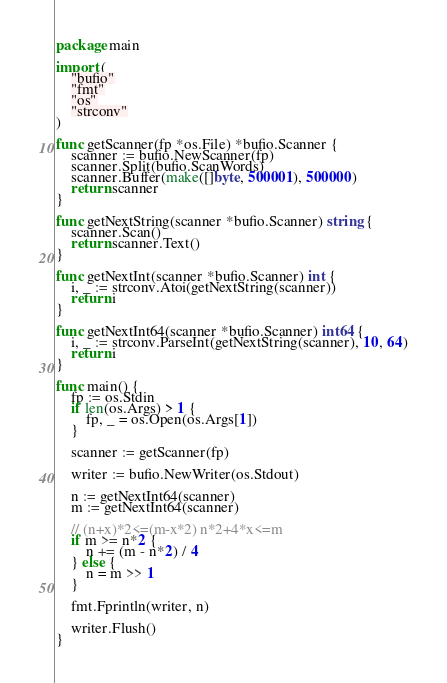Convert code to text. <code><loc_0><loc_0><loc_500><loc_500><_Go_>package main

import (
	"bufio"
	"fmt"
	"os"
	"strconv"
)

func getScanner(fp *os.File) *bufio.Scanner {
	scanner := bufio.NewScanner(fp)
	scanner.Split(bufio.ScanWords)
	scanner.Buffer(make([]byte, 500001), 500000)
	return scanner
}

func getNextString(scanner *bufio.Scanner) string {
	scanner.Scan()
	return scanner.Text()
}

func getNextInt(scanner *bufio.Scanner) int {
	i, _ := strconv.Atoi(getNextString(scanner))
	return i
}

func getNextInt64(scanner *bufio.Scanner) int64 {
	i, _ := strconv.ParseInt(getNextString(scanner), 10, 64)
	return i
}

func main() {
	fp := os.Stdin
	if len(os.Args) > 1 {
		fp, _ = os.Open(os.Args[1])
	}

	scanner := getScanner(fp)

	writer := bufio.NewWriter(os.Stdout)

	n := getNextInt64(scanner)
	m := getNextInt64(scanner)

	// (n+x)*2<=(m-x*2) n*2+4*x<=m
	if m >= n*2 {
		n += (m - n*2) / 4
	} else {
		n = m >> 1
	}

	fmt.Fprintln(writer, n)

	writer.Flush()
}
</code> 